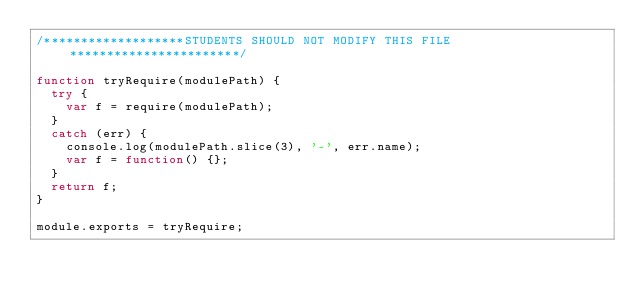Convert code to text. <code><loc_0><loc_0><loc_500><loc_500><_JavaScript_>/*******************STUDENTS SHOULD NOT MODIFY THIS FILE***********************/

function tryRequire(modulePath) {
  try {
    var f = require(modulePath);
  }
  catch (err) {
    console.log(modulePath.slice(3), '-', err.name);
    var f = function() {};
  }
  return f;
}

module.exports = tryRequire;
</code> 